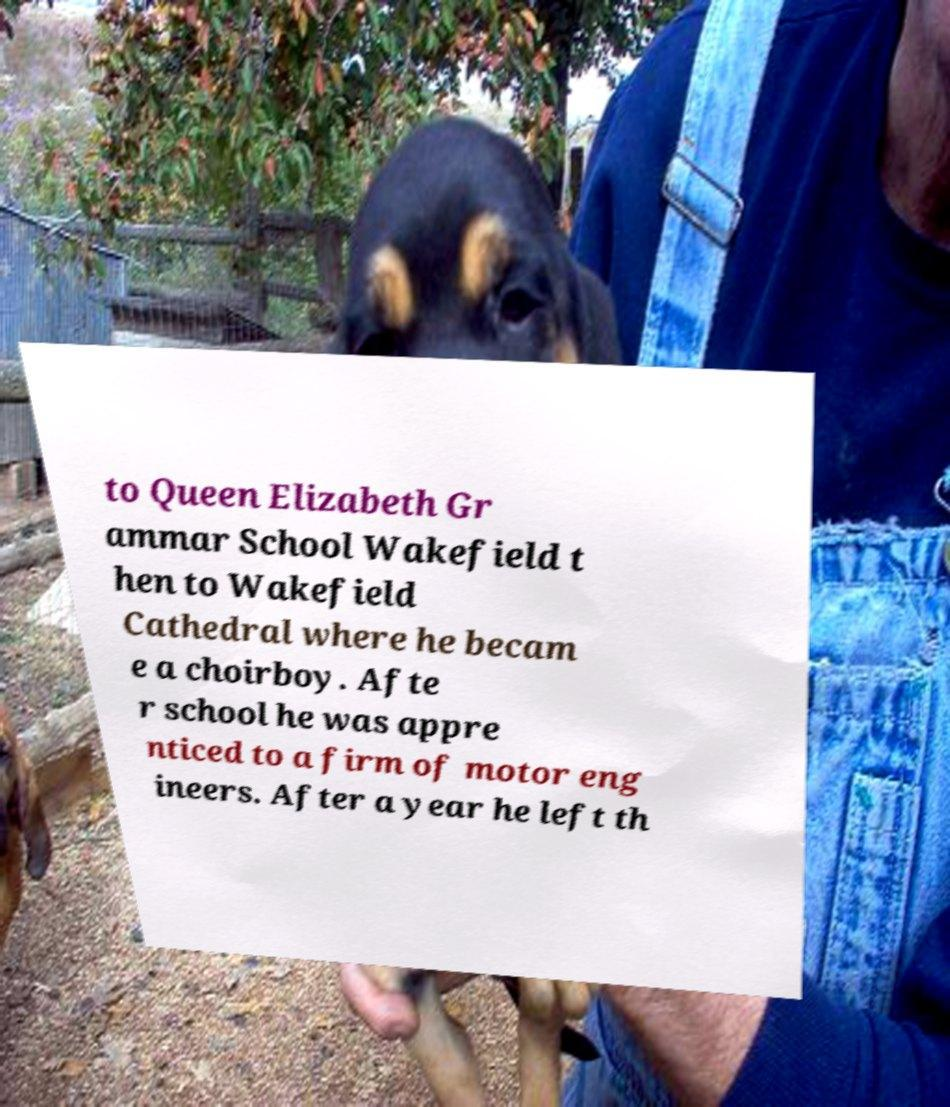Could you assist in decoding the text presented in this image and type it out clearly? to Queen Elizabeth Gr ammar School Wakefield t hen to Wakefield Cathedral where he becam e a choirboy. Afte r school he was appre nticed to a firm of motor eng ineers. After a year he left th 